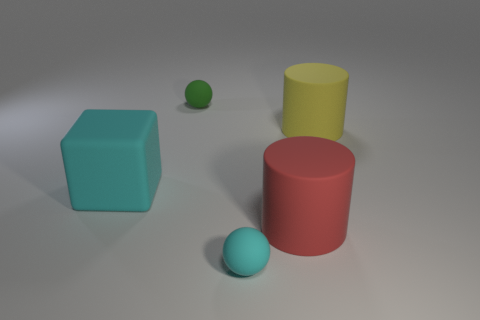What could be the relative sizes of these objects? Visual estimation suggests the red cylinder is the largest object, followed by the yellow cylinder, blue cube, green sphere, and finally the smallest, the blue sphere. Could these objects be used to teach something? Yes, they could be used as educational aids to teach about colors, shapes, volumes, and spatial relationships. 